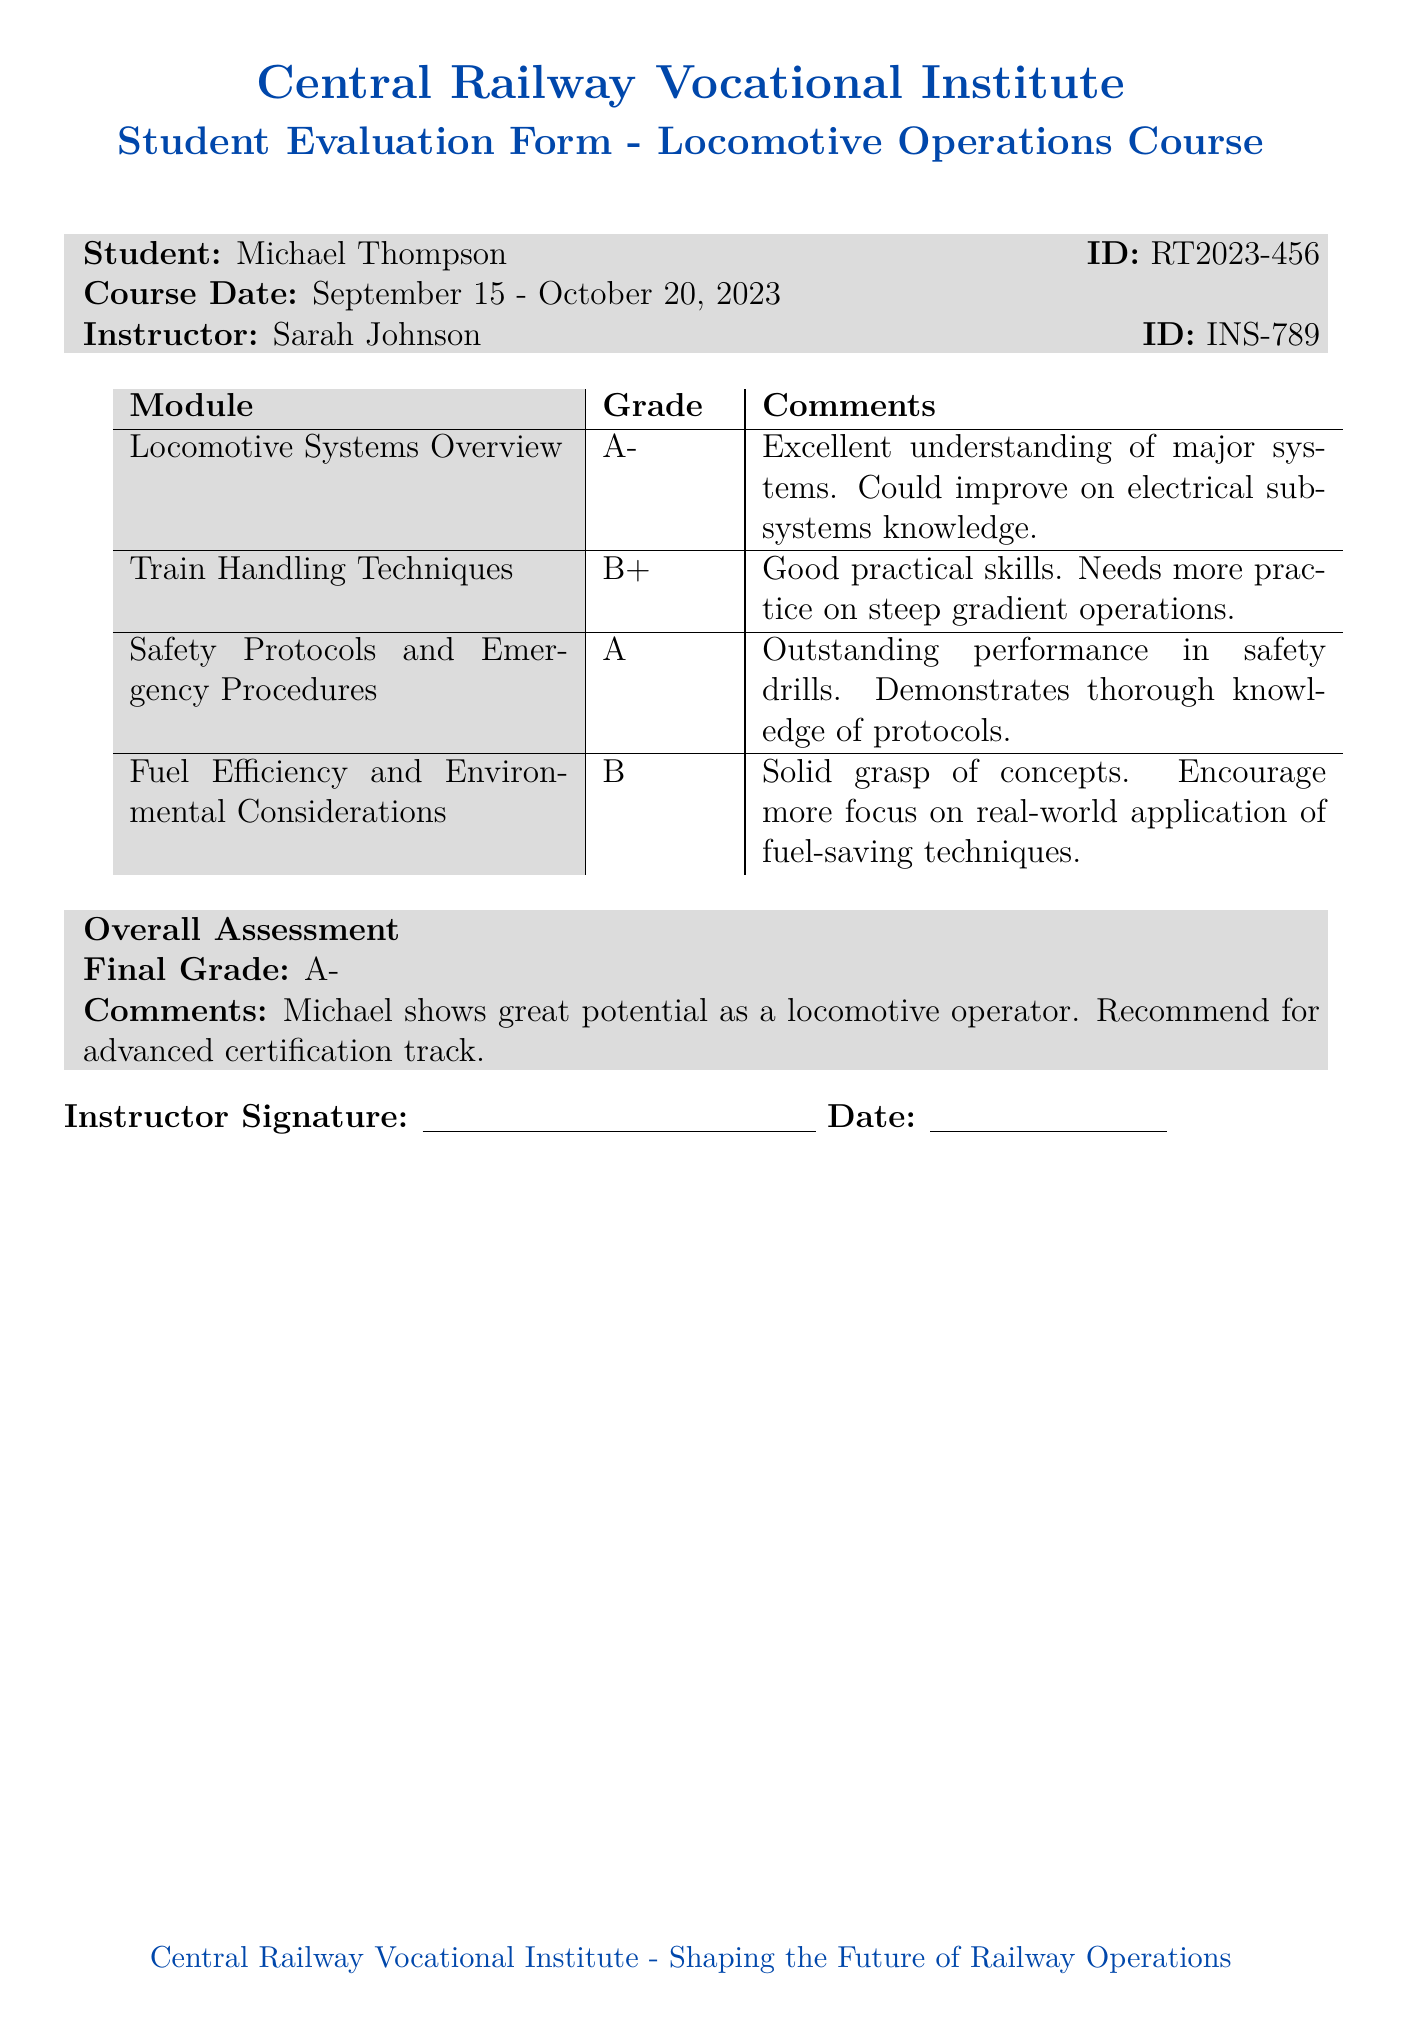What is the student's name? The student's name is stated clearly in the document.
Answer: Michael Thompson What is the student's ID? The student's ID is included in the header section of the evaluation form.
Answer: RT2023-456 What is the course date range? The course date range is provided following the student's name and ID.
Answer: September 15 - October 20, 2023 What grade did the student receive in Safety Protocols and Emergency Procedures? The grade for this module is listed in the table of grades and comments.
Answer: A What comment is given for the Fuel Efficiency and Environmental Considerations module? The comments section provides specific feedback on this module.
Answer: Solid grasp of concepts. Encourage more focus on real-world application of fuel-saving techniques What is the overall final grade? The overall final grade is provided in the conclusion of the evaluation form.
Answer: A- Who is the instructor? The instructor's name is included in the introductory section of the document.
Answer: Sarah Johnson What recommendation is made for the student in the overall assessment? The recommendation is clearly stated in the overall assessment section.
Answer: Recommend for advanced certification track What area could the student improve in according to the comments? The document includes specific areas for possible improvement.
Answer: Electrical subsystems knowledge 